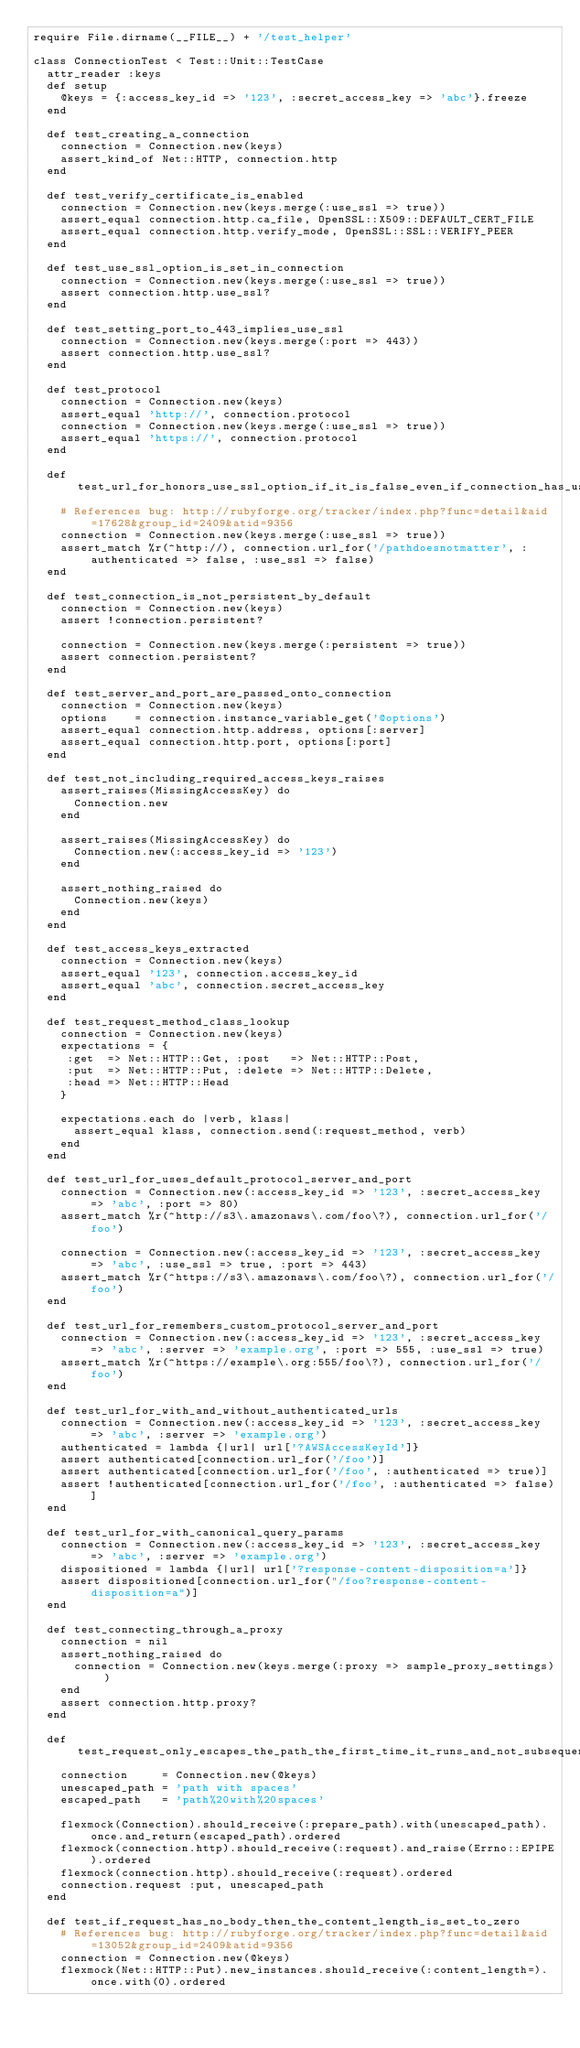Convert code to text. <code><loc_0><loc_0><loc_500><loc_500><_Ruby_>require File.dirname(__FILE__) + '/test_helper'

class ConnectionTest < Test::Unit::TestCase
  attr_reader :keys
  def setup
    @keys = {:access_key_id => '123', :secret_access_key => 'abc'}.freeze
  end
  
  def test_creating_a_connection
    connection = Connection.new(keys)
    assert_kind_of Net::HTTP, connection.http
  end
  
  def test_verify_certificate_is_enabled
    connection = Connection.new(keys.merge(:use_ssl => true))
    assert_equal connection.http.ca_file, OpenSSL::X509::DEFAULT_CERT_FILE
    assert_equal connection.http.verify_mode, OpenSSL::SSL::VERIFY_PEER
  end

  def test_use_ssl_option_is_set_in_connection
    connection = Connection.new(keys.merge(:use_ssl => true))
    assert connection.http.use_ssl?
  end
  
  def test_setting_port_to_443_implies_use_ssl
    connection = Connection.new(keys.merge(:port => 443))
    assert connection.http.use_ssl?
  end
  
  def test_protocol
    connection = Connection.new(keys)
    assert_equal 'http://', connection.protocol
    connection = Connection.new(keys.merge(:use_ssl => true))
    assert_equal 'https://', connection.protocol
  end
  
  def test_url_for_honors_use_ssl_option_if_it_is_false_even_if_connection_has_use_ssl_option_set
    # References bug: http://rubyforge.org/tracker/index.php?func=detail&aid=17628&group_id=2409&atid=9356
    connection = Connection.new(keys.merge(:use_ssl => true))
    assert_match %r(^http://), connection.url_for('/pathdoesnotmatter', :authenticated => false, :use_ssl => false)
  end
  
  def test_connection_is_not_persistent_by_default
    connection = Connection.new(keys)
    assert !connection.persistent?
    
    connection = Connection.new(keys.merge(:persistent => true))
    assert connection.persistent?
  end
  
  def test_server_and_port_are_passed_onto_connection
    connection = Connection.new(keys)
    options    = connection.instance_variable_get('@options')
    assert_equal connection.http.address, options[:server]
    assert_equal connection.http.port, options[:port]
  end
  
  def test_not_including_required_access_keys_raises
    assert_raises(MissingAccessKey) do
      Connection.new
    end
    
    assert_raises(MissingAccessKey) do
      Connection.new(:access_key_id => '123')
    end
    
    assert_nothing_raised do
      Connection.new(keys)
    end
  end
  
  def test_access_keys_extracted
    connection = Connection.new(keys)
    assert_equal '123', connection.access_key_id
    assert_equal 'abc', connection.secret_access_key
  end
  
  def test_request_method_class_lookup
    connection = Connection.new(keys)
    expectations = {
     :get  => Net::HTTP::Get, :post   => Net::HTTP::Post,
     :put  => Net::HTTP::Put, :delete => Net::HTTP::Delete,
     :head => Net::HTTP::Head
    }
    
    expectations.each do |verb, klass|
      assert_equal klass, connection.send(:request_method, verb)
    end
  end

  def test_url_for_uses_default_protocol_server_and_port
    connection = Connection.new(:access_key_id => '123', :secret_access_key => 'abc', :port => 80)
    assert_match %r(^http://s3\.amazonaws\.com/foo\?), connection.url_for('/foo')

    connection = Connection.new(:access_key_id => '123', :secret_access_key => 'abc', :use_ssl => true, :port => 443)
    assert_match %r(^https://s3\.amazonaws\.com/foo\?), connection.url_for('/foo')
  end

  def test_url_for_remembers_custom_protocol_server_and_port
    connection = Connection.new(:access_key_id => '123', :secret_access_key => 'abc', :server => 'example.org', :port => 555, :use_ssl => true)
    assert_match %r(^https://example\.org:555/foo\?), connection.url_for('/foo')
  end

  def test_url_for_with_and_without_authenticated_urls
    connection = Connection.new(:access_key_id => '123', :secret_access_key => 'abc', :server => 'example.org')
    authenticated = lambda {|url| url['?AWSAccessKeyId']}
    assert authenticated[connection.url_for('/foo')]
    assert authenticated[connection.url_for('/foo', :authenticated => true)]
    assert !authenticated[connection.url_for('/foo', :authenticated => false)]
  end

  def test_url_for_with_canonical_query_params
    connection = Connection.new(:access_key_id => '123', :secret_access_key => 'abc', :server => 'example.org')
    dispositioned = lambda {|url| url['?response-content-disposition=a']}
    assert dispositioned[connection.url_for("/foo?response-content-disposition=a")]
  end
  
  def test_connecting_through_a_proxy
    connection = nil
    assert_nothing_raised do
      connection = Connection.new(keys.merge(:proxy => sample_proxy_settings))
    end
    assert connection.http.proxy?
  end
  
  def test_request_only_escapes_the_path_the_first_time_it_runs_and_not_subsequent_times
    connection     = Connection.new(@keys)
    unescaped_path = 'path with spaces'
    escaped_path   = 'path%20with%20spaces'
    
    flexmock(Connection).should_receive(:prepare_path).with(unescaped_path).once.and_return(escaped_path).ordered
    flexmock(connection.http).should_receive(:request).and_raise(Errno::EPIPE).ordered
    flexmock(connection.http).should_receive(:request).ordered
    connection.request :put, unescaped_path
  end
  
  def test_if_request_has_no_body_then_the_content_length_is_set_to_zero
    # References bug: http://rubyforge.org/tracker/index.php?func=detail&aid=13052&group_id=2409&atid=9356
    connection = Connection.new(@keys)
    flexmock(Net::HTTP::Put).new_instances.should_receive(:content_length=).once.with(0).ordered</code> 